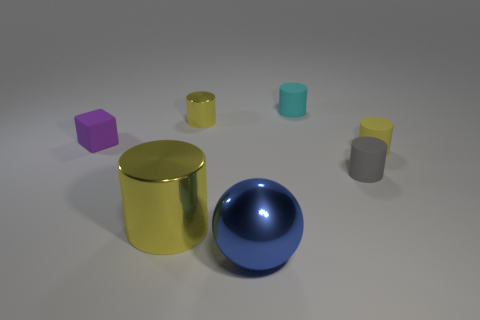Subtract all red blocks. How many yellow cylinders are left? 3 Subtract all cyan cylinders. How many cylinders are left? 4 Subtract all small gray cylinders. How many cylinders are left? 4 Subtract all red cylinders. Subtract all blue balls. How many cylinders are left? 5 Add 2 blue balls. How many objects exist? 9 Subtract all spheres. How many objects are left? 6 Subtract all small blue metal cylinders. Subtract all metal balls. How many objects are left? 6 Add 1 tiny cubes. How many tiny cubes are left? 2 Add 4 tiny shiny spheres. How many tiny shiny spheres exist? 4 Subtract 2 yellow cylinders. How many objects are left? 5 